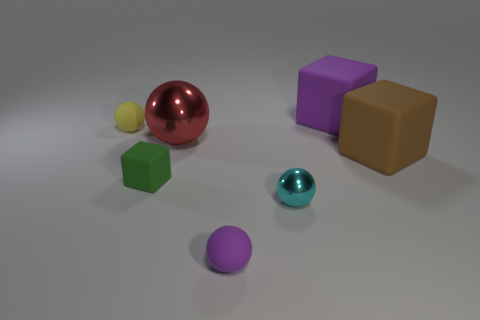Are the thing to the left of the tiny green block and the small cyan thing made of the same material?
Your answer should be very brief. No. Are there fewer small cyan spheres in front of the tiny metal object than purple rubber cylinders?
Offer a very short reply. No. What shape is the shiny object in front of the red shiny thing?
Your response must be concise. Sphere. What is the shape of the matte object that is the same size as the brown cube?
Make the answer very short. Cube. Is there another tiny cyan shiny object of the same shape as the cyan shiny object?
Provide a succinct answer. No. There is a big rubber object that is behind the yellow matte object; is its shape the same as the purple thing that is in front of the yellow ball?
Keep it short and to the point. No. What material is the purple block that is the same size as the brown object?
Make the answer very short. Rubber. How many other things are there of the same material as the purple ball?
Provide a succinct answer. 4. The large rubber thing that is behind the matte cube that is on the right side of the purple rubber block is what shape?
Keep it short and to the point. Cube. What number of objects are either tiny red balls or purple matte objects in front of the yellow matte object?
Provide a short and direct response. 1. 